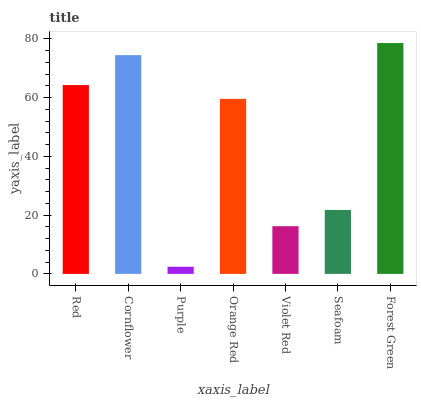Is Purple the minimum?
Answer yes or no. Yes. Is Forest Green the maximum?
Answer yes or no. Yes. Is Cornflower the minimum?
Answer yes or no. No. Is Cornflower the maximum?
Answer yes or no. No. Is Cornflower greater than Red?
Answer yes or no. Yes. Is Red less than Cornflower?
Answer yes or no. Yes. Is Red greater than Cornflower?
Answer yes or no. No. Is Cornflower less than Red?
Answer yes or no. No. Is Orange Red the high median?
Answer yes or no. Yes. Is Orange Red the low median?
Answer yes or no. Yes. Is Forest Green the high median?
Answer yes or no. No. Is Purple the low median?
Answer yes or no. No. 